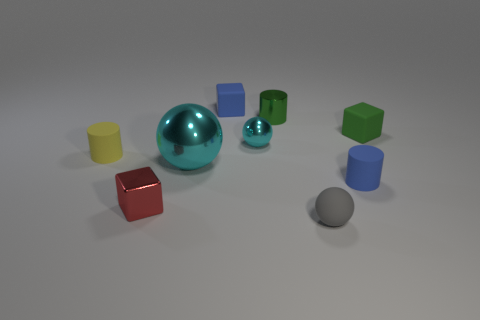There is a tiny thing that is the same color as the big thing; what shape is it?
Your response must be concise. Sphere. The cylinder that is the same material as the red block is what size?
Your answer should be compact. Small. What is the shape of the metal thing that is behind the tiny green block?
Ensure brevity in your answer.  Cylinder. Do the rubber block that is to the left of the blue rubber cylinder and the tiny cube in front of the small blue cylinder have the same color?
Provide a succinct answer. No. There is another metallic ball that is the same color as the big metallic sphere; what is its size?
Keep it short and to the point. Small. Is there a small cyan metallic ball?
Keep it short and to the point. Yes. There is a cyan thing that is in front of the rubber cylinder that is on the left side of the tiny matte thing that is behind the small green matte block; what is its shape?
Make the answer very short. Sphere. How many tiny matte things are in front of the tiny gray rubber object?
Your answer should be compact. 0. Is the small blue object to the left of the small blue rubber cylinder made of the same material as the large cyan sphere?
Offer a very short reply. No. What number of other objects are the same shape as the small green matte object?
Offer a very short reply. 2. 